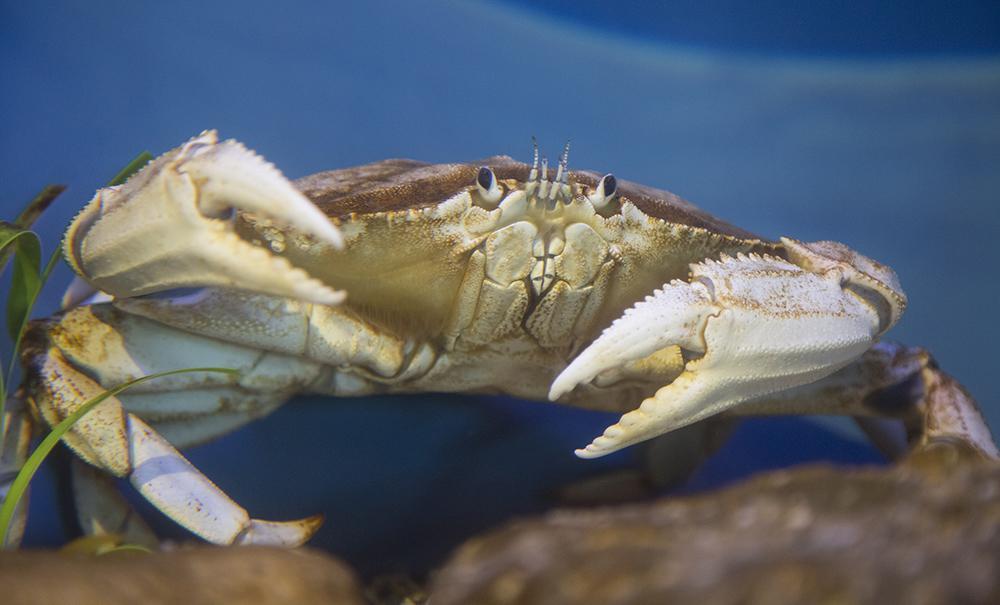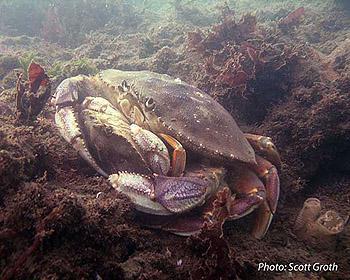The first image is the image on the left, the second image is the image on the right. For the images shown, is this caption "In at least one image there is an ungloved hand holding a live crab." true? Answer yes or no. No. The first image is the image on the left, the second image is the image on the right. Considering the images on both sides, is "Each image includes a forward-facing crab, and in one image, a crab is held by a bare hand." valid? Answer yes or no. No. 